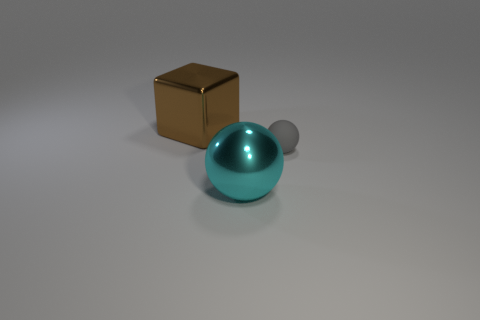Add 2 big things. How many objects exist? 5 Subtract all spheres. How many objects are left? 1 Add 2 cyan metallic spheres. How many cyan metallic spheres are left? 3 Add 1 tiny brown metallic objects. How many tiny brown metallic objects exist? 1 Subtract 0 green spheres. How many objects are left? 3 Subtract all big metal cubes. Subtract all cyan shiny spheres. How many objects are left? 1 